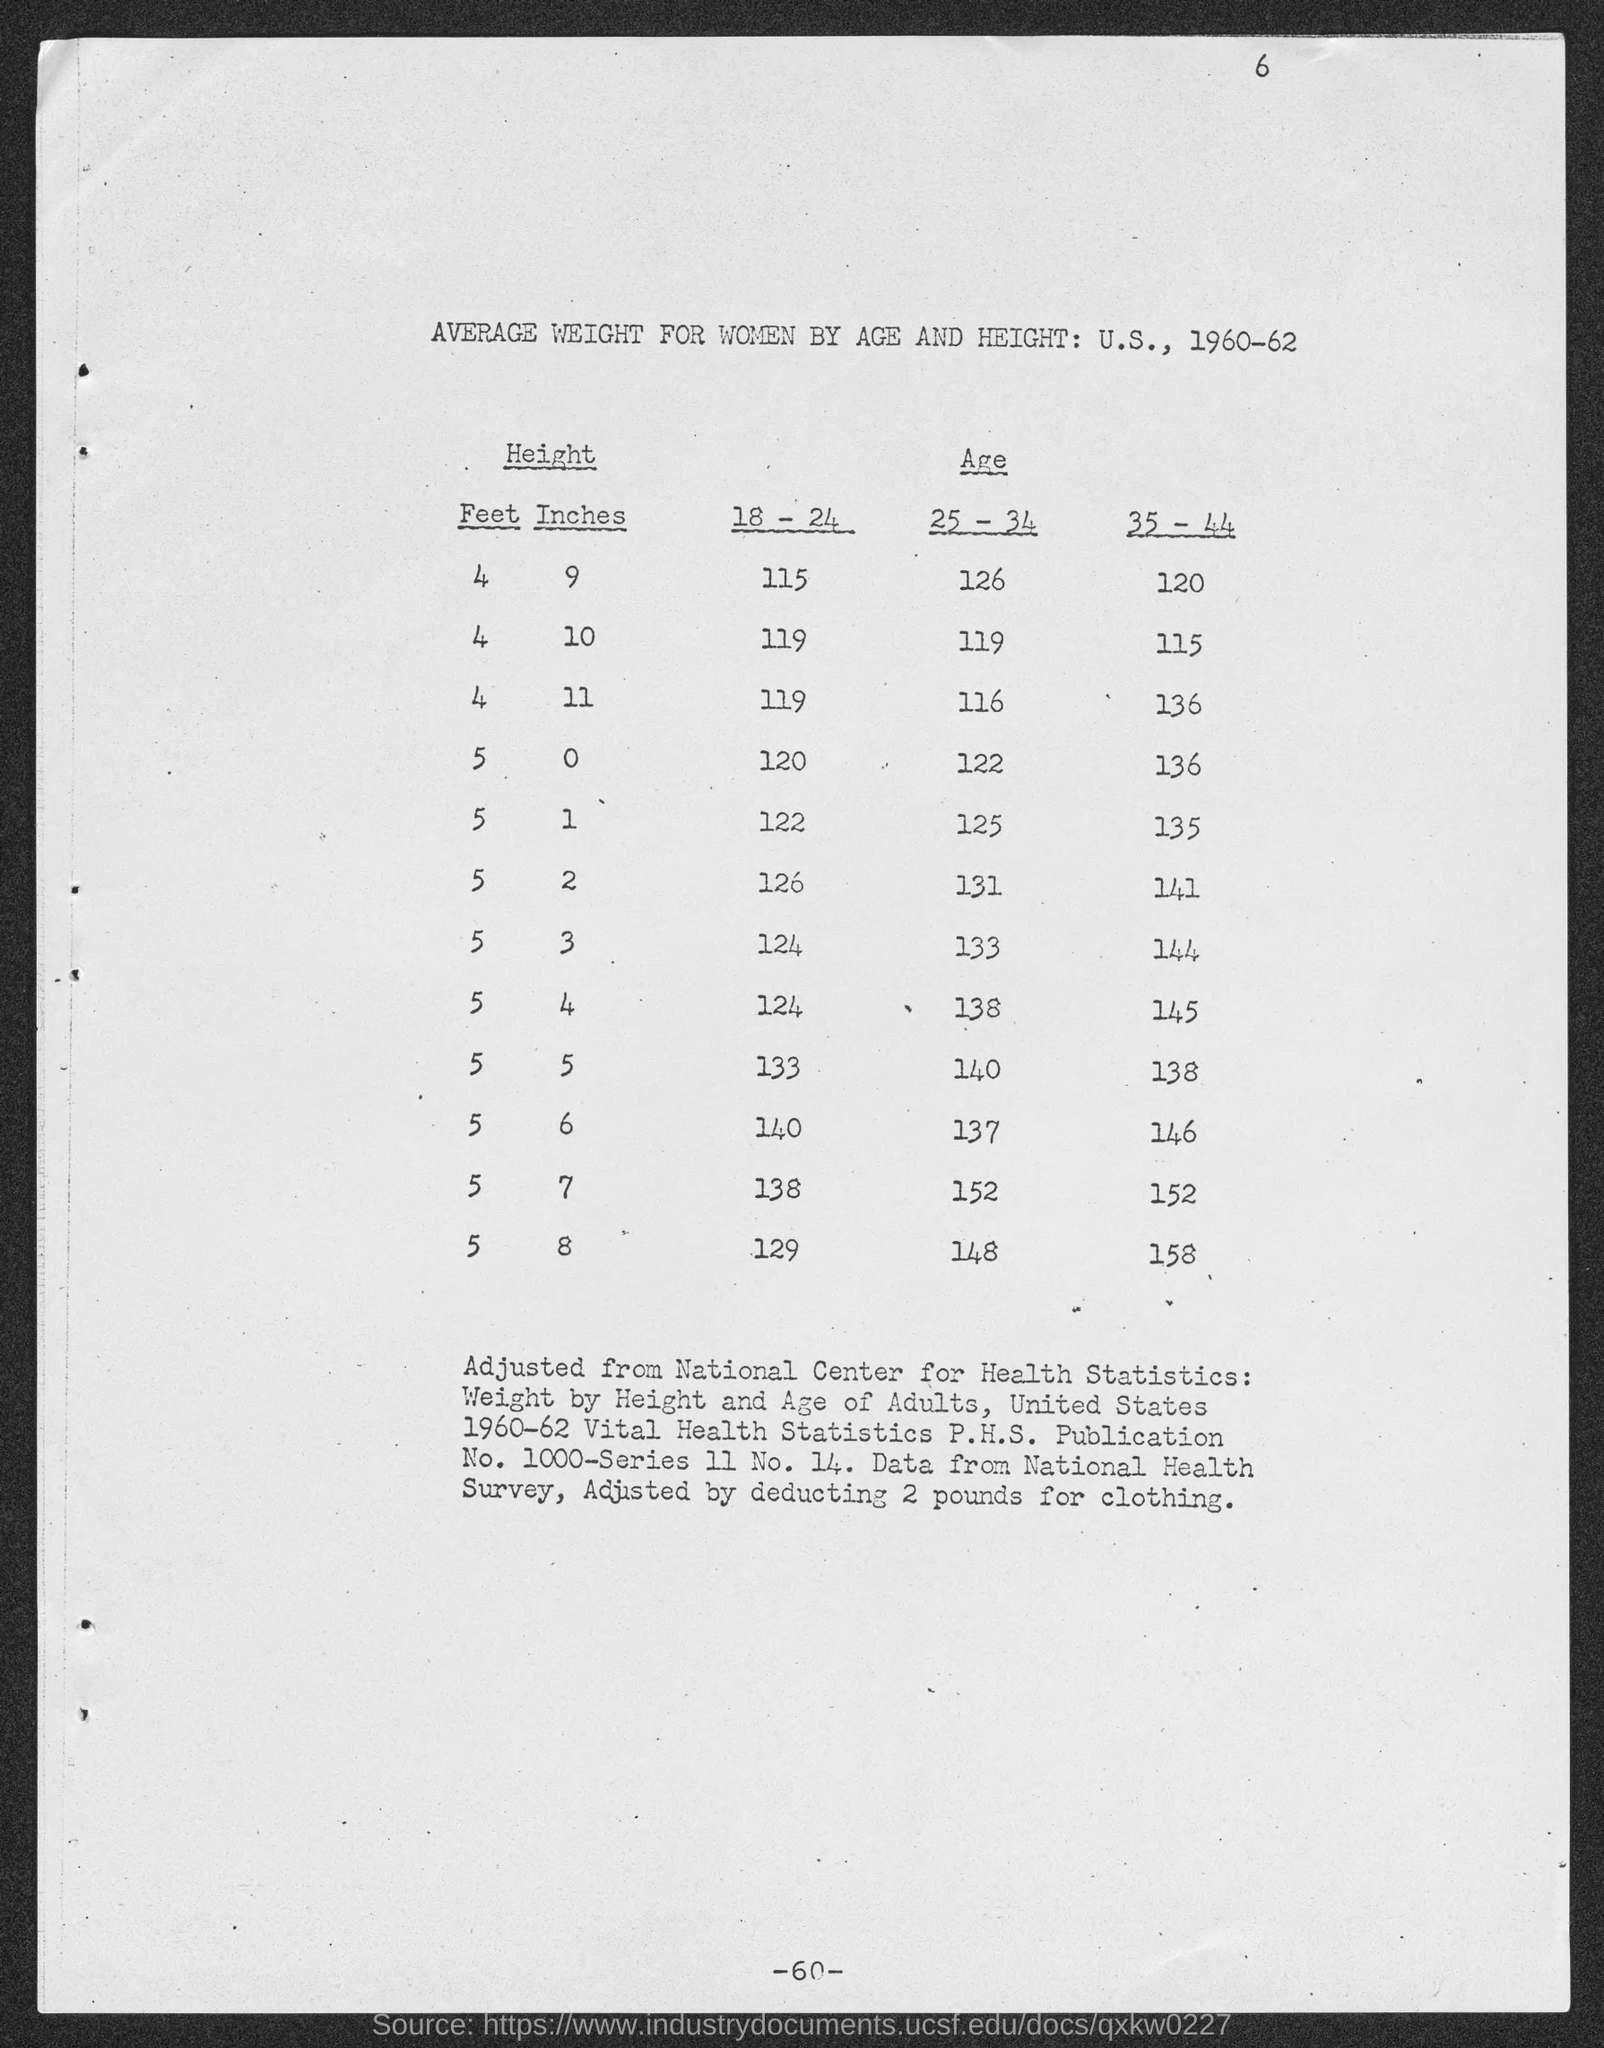What adjustments were made to these weight figures and why? The weights listed in the table have been adjusted by deducting 2 pounds to account for clothing, as stated at the bottom of the document. This adjustment is meant to provide a more accurate estimate of the women's actual body weight without the additional weight of clothing, which could vary between individuals but averages around 2 pounds. 